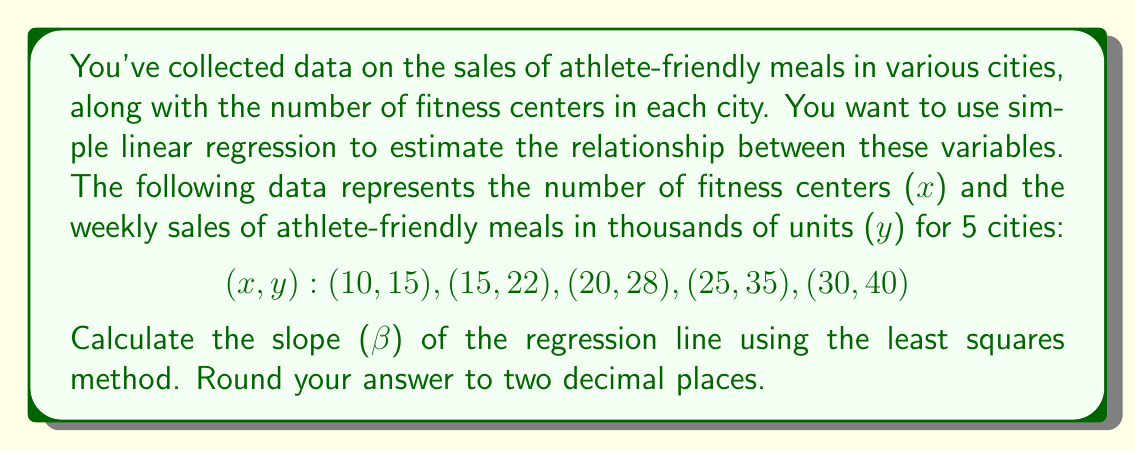What is the answer to this math problem? To calculate the slope (β) of the regression line using the least squares method, we'll use the formula:

$$ \beta = \frac{n\sum xy - \sum x \sum y}{n\sum x^2 - (\sum x)^2} $$

Where:
n = number of data points
x = number of fitness centers
y = weekly sales of athlete-friendly meals (in thousands)

Let's calculate the required sums:

1. $n = 5$
2. $\sum x = 10 + 15 + 20 + 25 + 30 = 100$
3. $\sum y = 15 + 22 + 28 + 35 + 40 = 140$
4. $\sum xy = (10 * 15) + (15 * 22) + (20 * 28) + (25 * 35) + (30 * 40) = 3,100$
5. $\sum x^2 = 10^2 + 15^2 + 20^2 + 25^2 + 30^2 = 2,250$

Now, let's substitute these values into the formula:

$$ \beta = \frac{5(3,100) - (100)(140)}{5(2,250) - (100)^2} $$

$$ \beta = \frac{15,500 - 14,000}{11,250 - 10,000} $$

$$ \beta = \frac{1,500}{1,250} $$

$$ \beta = 1.2 $$

Therefore, the slope of the regression line is 1.2, rounded to two decimal places.
Answer: 1.20 